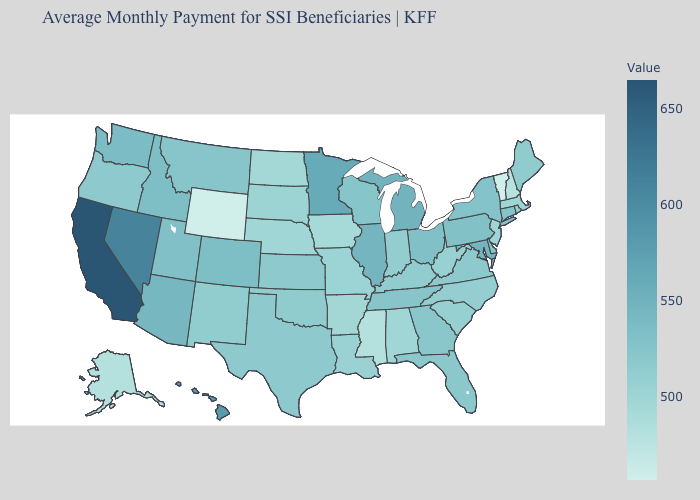Which states hav the highest value in the South?
Give a very brief answer. Maryland. Among the states that border Idaho , which have the lowest value?
Be succinct. Wyoming. Which states have the highest value in the USA?
Be succinct. California. Which states have the highest value in the USA?
Short answer required. California. Among the states that border North Dakota , which have the highest value?
Write a very short answer. Minnesota. Among the states that border Virginia , does Kentucky have the highest value?
Write a very short answer. No. Which states hav the highest value in the MidWest?
Short answer required. Minnesota. Among the states that border New Hampshire , which have the lowest value?
Concise answer only. Vermont. Among the states that border Colorado , which have the highest value?
Short answer required. Arizona. 